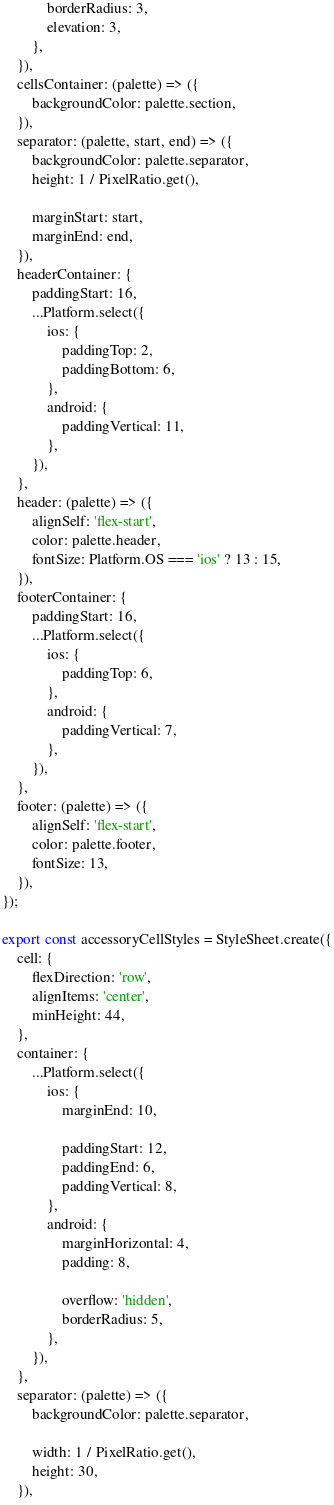Convert code to text. <code><loc_0><loc_0><loc_500><loc_500><_JavaScript_>			borderRadius: 3,
			elevation: 3,
		},
	}),
	cellsContainer: (palette) => ({
		backgroundColor: palette.section,
	}),
	separator: (palette, start, end) => ({
		backgroundColor: palette.separator,
		height: 1 / PixelRatio.get(),

		marginStart: start,
		marginEnd: end,
	}),
	headerContainer: {
		paddingStart: 16,
		...Platform.select({
			ios: {
				paddingTop: 2,
				paddingBottom: 6,
			},
			android: {
				paddingVertical: 11,
			},
		}),
	},
	header: (palette) => ({
		alignSelf: 'flex-start',
		color: palette.header,
		fontSize: Platform.OS === 'ios' ? 13 : 15,
	}),
	footerContainer: {
		paddingStart: 16,
		...Platform.select({
			ios: {
				paddingTop: 6,
			},
			android: {
				paddingVertical: 7,
			},
		}),
	},
	footer: (palette) => ({
		alignSelf: 'flex-start',
		color: palette.footer,
		fontSize: 13,
	}),
});

export const accessoryCellStyles = StyleSheet.create({
	cell: {
		flexDirection: 'row',
		alignItems: 'center',
		minHeight: 44,
	},
	container: {
		...Platform.select({
			ios: {
				marginEnd: 10,

				paddingStart: 12,
				paddingEnd: 6,
				paddingVertical: 8,
			},
			android: {
				marginHorizontal: 4,
				padding: 8,

				overflow: 'hidden',
				borderRadius: 5,
			},
		}),
	},
	separator: (palette) => ({
		backgroundColor: palette.separator,

		width: 1 / PixelRatio.get(),
		height: 30,
	}),</code> 